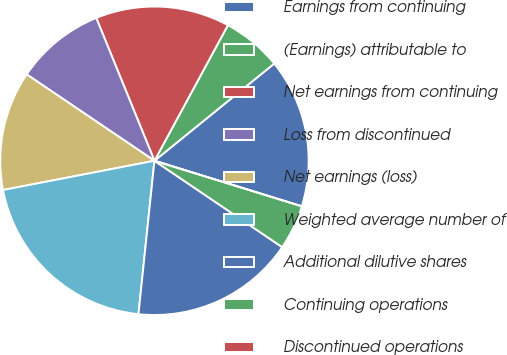<chart> <loc_0><loc_0><loc_500><loc_500><pie_chart><fcel>Earnings from continuing<fcel>(Earnings) attributable to<fcel>Net earnings from continuing<fcel>Loss from discontinued<fcel>Net earnings (loss)<fcel>Weighted average number of<fcel>Additional dilutive shares<fcel>Continuing operations<fcel>Discontinued operations<nl><fcel>15.62%<fcel>6.25%<fcel>14.06%<fcel>9.38%<fcel>12.5%<fcel>20.31%<fcel>17.19%<fcel>4.69%<fcel>0.0%<nl></chart> 